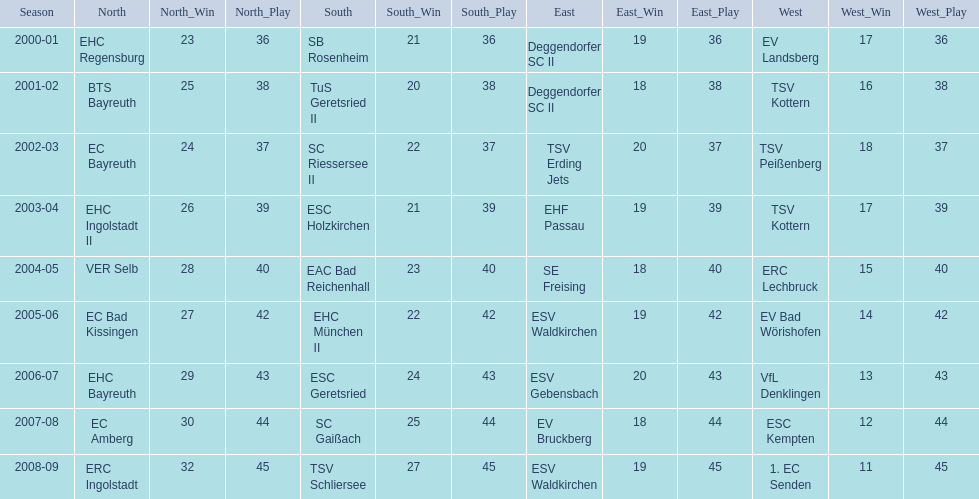What was the north's earliest club in the 2000s? EHC Regensburg. 